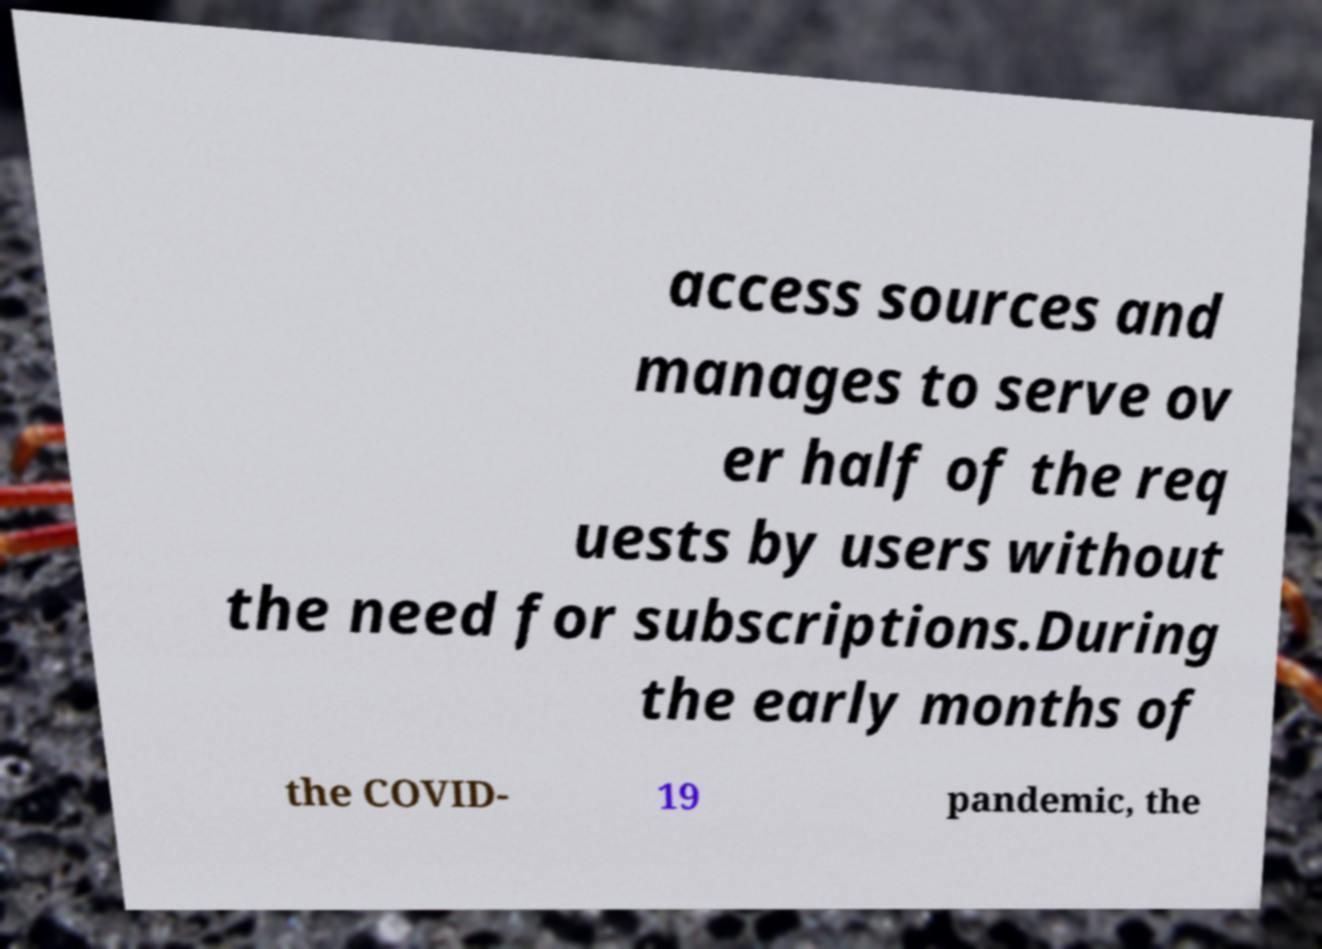Please identify and transcribe the text found in this image. access sources and manages to serve ov er half of the req uests by users without the need for subscriptions.During the early months of the COVID- 19 pandemic, the 